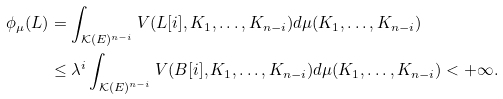Convert formula to latex. <formula><loc_0><loc_0><loc_500><loc_500>\phi _ { \mu } ( L ) & = \int _ { \mathcal { K } ( E ) ^ { n - i } } V ( L [ i ] , K _ { 1 } , \dots , K _ { n - i } ) d \mu ( K _ { 1 } , \dots , K _ { n - i } ) \\ & \leq \lambda ^ { i } \int _ { \mathcal { K } ( E ) ^ { n - i } } V ( B [ i ] , K _ { 1 } , \dots , K _ { n - i } ) d \mu ( K _ { 1 } , \dots , K _ { n - i } ) < + \infty .</formula> 